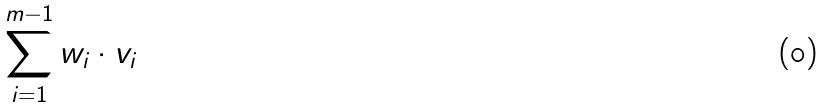<formula> <loc_0><loc_0><loc_500><loc_500>\sum _ { i = 1 } ^ { m - 1 } w _ { i } \cdot v _ { i }</formula> 